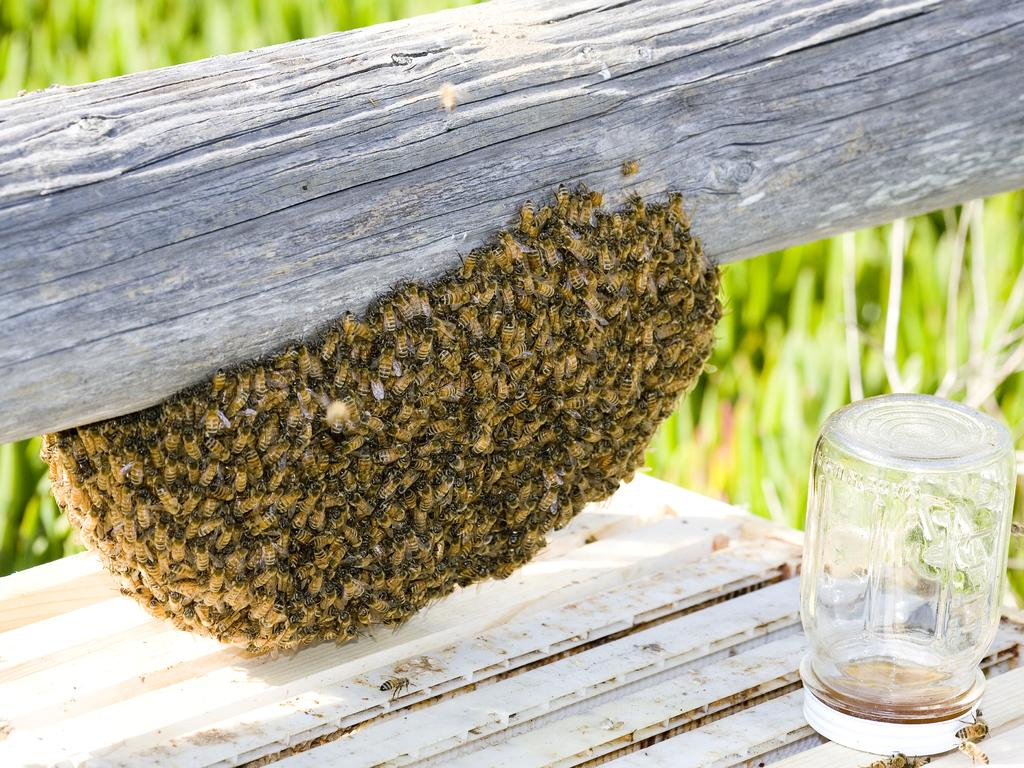What is the main subject of the image? The main subject of the image is a honeycomb with honey bees. Where is the honeycomb located? The honeycomb is attached to a tree trunk. What other object can be seen in the image? There is a glass jar with a lid in the image. Can you describe the background of the image? The background of the image is blurred. What type of bread is being used to brush the honeycomb in the image? There is no bread or brushing activity present in the image; it features a honeycomb with honey bees attached to a tree trunk and a glass jar with a lid. 